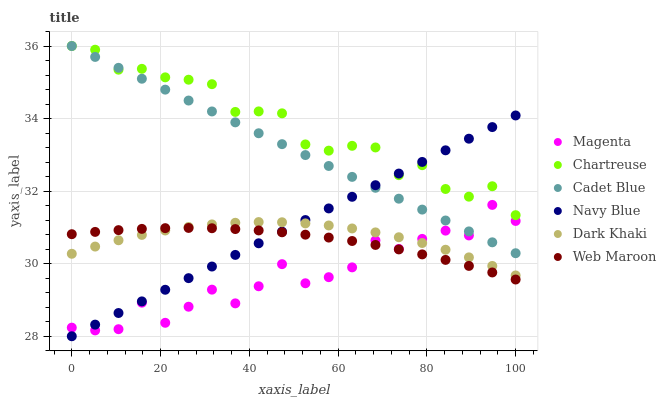Does Magenta have the minimum area under the curve?
Answer yes or no. Yes. Does Chartreuse have the maximum area under the curve?
Answer yes or no. Yes. Does Navy Blue have the minimum area under the curve?
Answer yes or no. No. Does Navy Blue have the maximum area under the curve?
Answer yes or no. No. Is Navy Blue the smoothest?
Answer yes or no. Yes. Is Magenta the roughest?
Answer yes or no. Yes. Is Web Maroon the smoothest?
Answer yes or no. No. Is Web Maroon the roughest?
Answer yes or no. No. Does Navy Blue have the lowest value?
Answer yes or no. Yes. Does Web Maroon have the lowest value?
Answer yes or no. No. Does Chartreuse have the highest value?
Answer yes or no. Yes. Does Navy Blue have the highest value?
Answer yes or no. No. Is Web Maroon less than Chartreuse?
Answer yes or no. Yes. Is Cadet Blue greater than Web Maroon?
Answer yes or no. Yes. Does Navy Blue intersect Chartreuse?
Answer yes or no. Yes. Is Navy Blue less than Chartreuse?
Answer yes or no. No. Is Navy Blue greater than Chartreuse?
Answer yes or no. No. Does Web Maroon intersect Chartreuse?
Answer yes or no. No. 